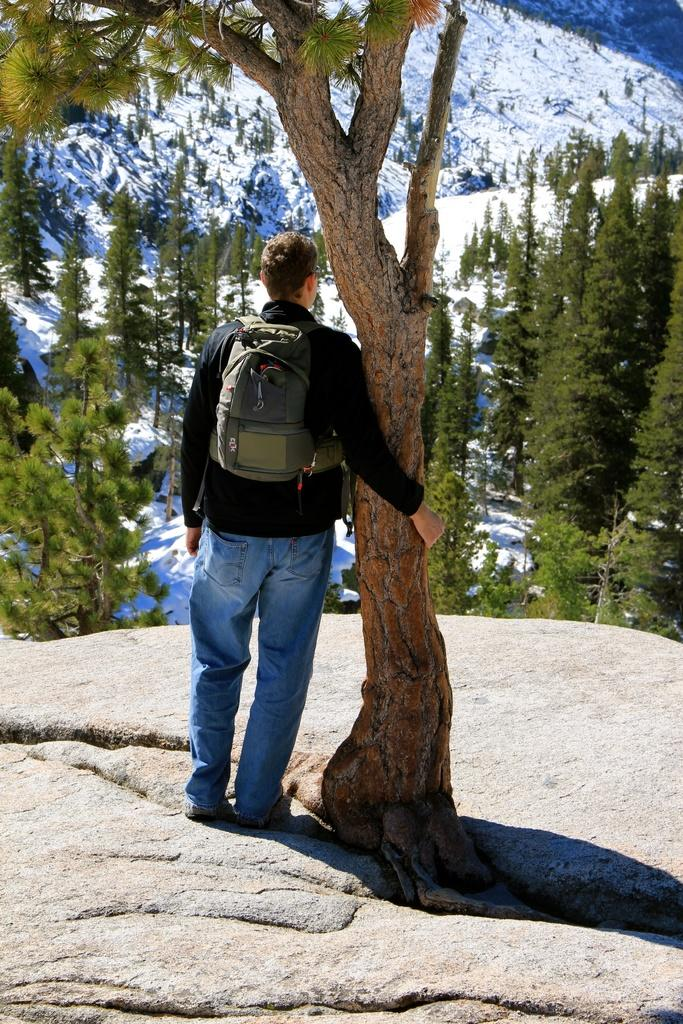What type of vegetation can be seen in the image? There are trees visible in the image. Can you describe the person in the image? There is a man standing in the image, wearing a black T-shirt and blue jeans. What is the man carrying on his back? The man has a backpack on his back. What type of creature is sitting on the man's shoulder in the image? There is no creature sitting on the man's shoulder in the image. What kind of pie is the man holding in the image? There is no pie present in the image. 